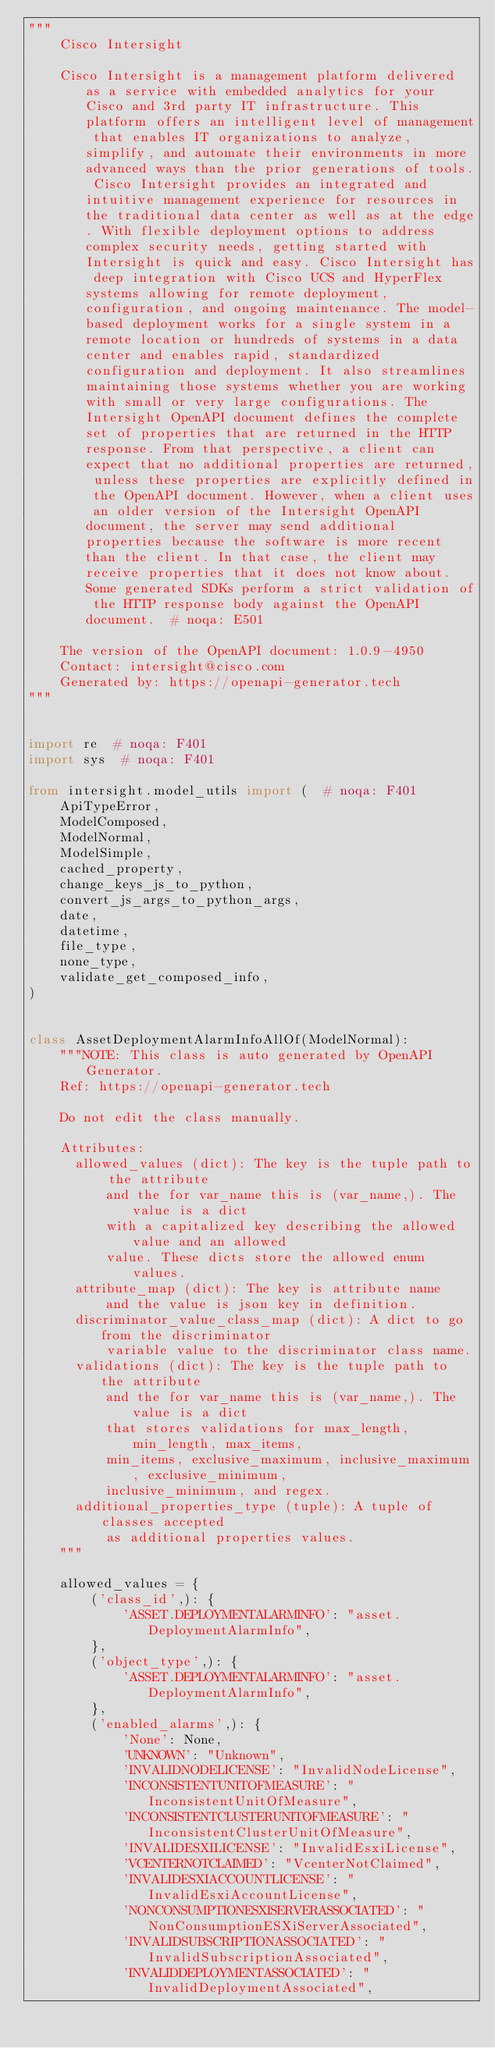<code> <loc_0><loc_0><loc_500><loc_500><_Python_>"""
    Cisco Intersight

    Cisco Intersight is a management platform delivered as a service with embedded analytics for your Cisco and 3rd party IT infrastructure. This platform offers an intelligent level of management that enables IT organizations to analyze, simplify, and automate their environments in more advanced ways than the prior generations of tools. Cisco Intersight provides an integrated and intuitive management experience for resources in the traditional data center as well as at the edge. With flexible deployment options to address complex security needs, getting started with Intersight is quick and easy. Cisco Intersight has deep integration with Cisco UCS and HyperFlex systems allowing for remote deployment, configuration, and ongoing maintenance. The model-based deployment works for a single system in a remote location or hundreds of systems in a data center and enables rapid, standardized configuration and deployment. It also streamlines maintaining those systems whether you are working with small or very large configurations. The Intersight OpenAPI document defines the complete set of properties that are returned in the HTTP response. From that perspective, a client can expect that no additional properties are returned, unless these properties are explicitly defined in the OpenAPI document. However, when a client uses an older version of the Intersight OpenAPI document, the server may send additional properties because the software is more recent than the client. In that case, the client may receive properties that it does not know about. Some generated SDKs perform a strict validation of the HTTP response body against the OpenAPI document.  # noqa: E501

    The version of the OpenAPI document: 1.0.9-4950
    Contact: intersight@cisco.com
    Generated by: https://openapi-generator.tech
"""


import re  # noqa: F401
import sys  # noqa: F401

from intersight.model_utils import (  # noqa: F401
    ApiTypeError,
    ModelComposed,
    ModelNormal,
    ModelSimple,
    cached_property,
    change_keys_js_to_python,
    convert_js_args_to_python_args,
    date,
    datetime,
    file_type,
    none_type,
    validate_get_composed_info,
)


class AssetDeploymentAlarmInfoAllOf(ModelNormal):
    """NOTE: This class is auto generated by OpenAPI Generator.
    Ref: https://openapi-generator.tech

    Do not edit the class manually.

    Attributes:
      allowed_values (dict): The key is the tuple path to the attribute
          and the for var_name this is (var_name,). The value is a dict
          with a capitalized key describing the allowed value and an allowed
          value. These dicts store the allowed enum values.
      attribute_map (dict): The key is attribute name
          and the value is json key in definition.
      discriminator_value_class_map (dict): A dict to go from the discriminator
          variable value to the discriminator class name.
      validations (dict): The key is the tuple path to the attribute
          and the for var_name this is (var_name,). The value is a dict
          that stores validations for max_length, min_length, max_items,
          min_items, exclusive_maximum, inclusive_maximum, exclusive_minimum,
          inclusive_minimum, and regex.
      additional_properties_type (tuple): A tuple of classes accepted
          as additional properties values.
    """

    allowed_values = {
        ('class_id',): {
            'ASSET.DEPLOYMENTALARMINFO': "asset.DeploymentAlarmInfo",
        },
        ('object_type',): {
            'ASSET.DEPLOYMENTALARMINFO': "asset.DeploymentAlarmInfo",
        },
        ('enabled_alarms',): {
            'None': None,
            'UNKNOWN': "Unknown",
            'INVALIDNODELICENSE': "InvalidNodeLicense",
            'INCONSISTENTUNITOFMEASURE': "InconsistentUnitOfMeasure",
            'INCONSISTENTCLUSTERUNITOFMEASURE': "InconsistentClusterUnitOfMeasure",
            'INVALIDESXILICENSE': "InvalidEsxiLicense",
            'VCENTERNOTCLAIMED': "VcenterNotClaimed",
            'INVALIDESXIACCOUNTLICENSE': "InvalidEsxiAccountLicense",
            'NONCONSUMPTIONESXISERVERASSOCIATED': "NonConsumptionESXiServerAssociated",
            'INVALIDSUBSCRIPTIONASSOCIATED': "InvalidSubscriptionAssociated",
            'INVALIDDEPLOYMENTASSOCIATED': "InvalidDeploymentAssociated",</code> 